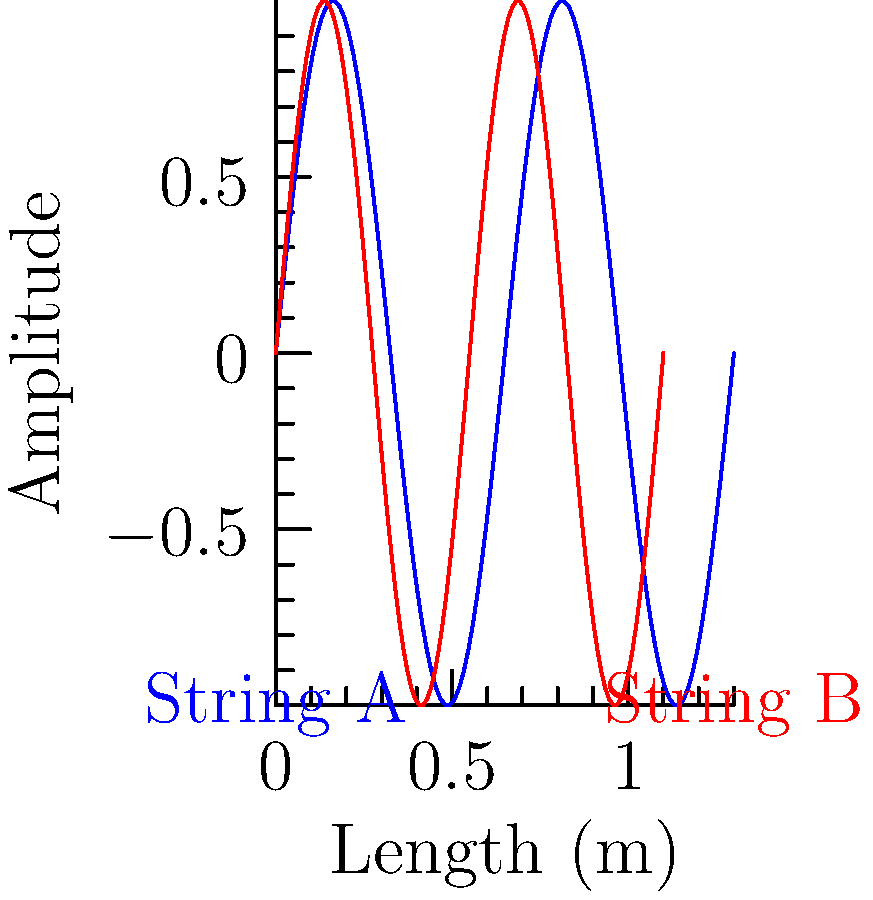As a country music enthusiast, you know the importance of a well-tuned guitar. The diagram shows the wave patterns of two guitar strings, A and B. String A has a wavelength of 0.65 meters, while String B has a wavelength of 0.55 meters. If the speed of sound in the strings is 330 m/s, calculate the frequency difference between these two strings. Which string would produce a higher pitch? Let's approach this step-by-step:

1) The formula for frequency is: $f = \frac{v}{\lambda}$, where $f$ is frequency, $v$ is velocity, and $\lambda$ is wavelength.

2) For String A:
   $f_A = \frac{330 \text{ m/s}}{0.65 \text{ m}} = 507.69 \text{ Hz}$

3) For String B:
   $f_B = \frac{330 \text{ m/s}}{0.55 \text{ m}} = 600 \text{ Hz}$

4) The frequency difference is:
   $600 \text{ Hz} - 507.69 \text{ Hz} = 92.31 \text{ Hz}$

5) String B has a higher frequency, so it would produce a higher pitch. This aligns with the inverse relationship between wavelength and frequency: shorter wavelengths produce higher frequencies and thus higher pitches.
Answer: 92.31 Hz; String B (higher pitch) 